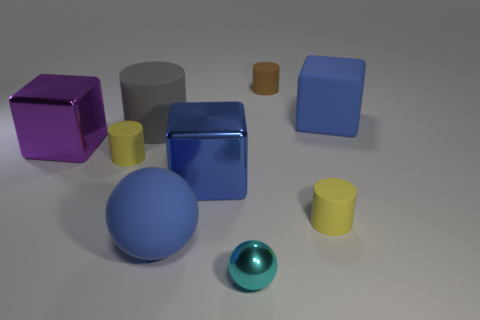Subtract all gray rubber cylinders. How many cylinders are left? 3 Add 1 small brown metal cylinders. How many objects exist? 10 Subtract 1 cylinders. How many cylinders are left? 3 Subtract all purple cubes. How many cubes are left? 2 Add 6 tiny cyan objects. How many tiny cyan objects are left? 7 Add 9 gray metal cubes. How many gray metal cubes exist? 9 Subtract 1 gray cylinders. How many objects are left? 8 Subtract all spheres. How many objects are left? 7 Subtract all green cylinders. Subtract all blue spheres. How many cylinders are left? 4 Subtract all gray cylinders. How many purple spheres are left? 0 